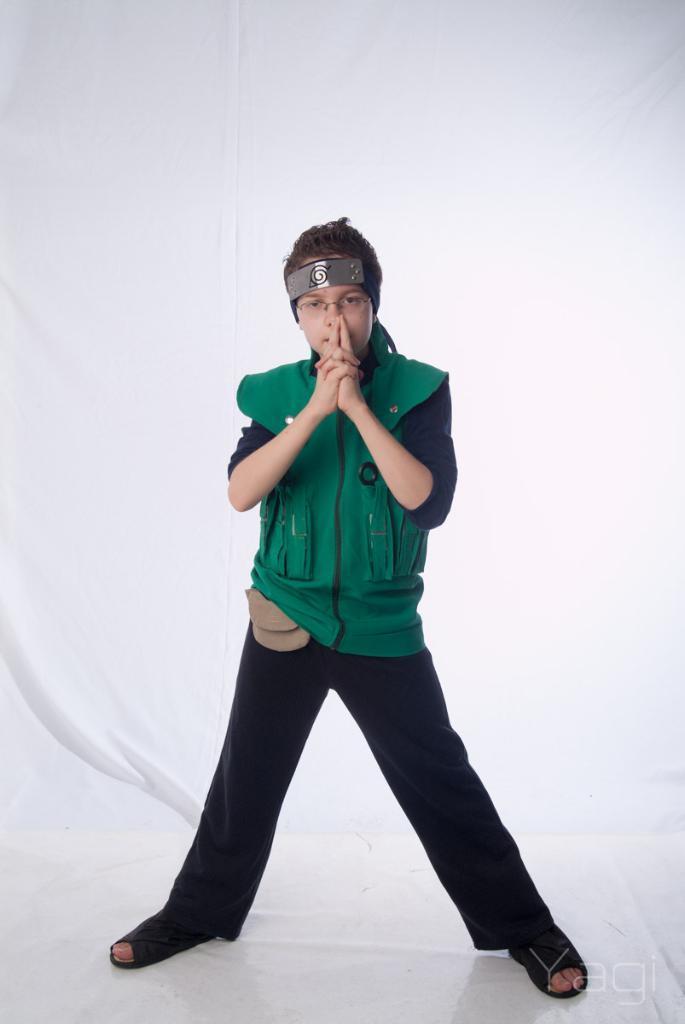In one or two sentences, can you explain what this image depicts? Here in this picture we can see a child standing on the floor and we can see he is wearing a jacket and behind him we can see a curtain present. 